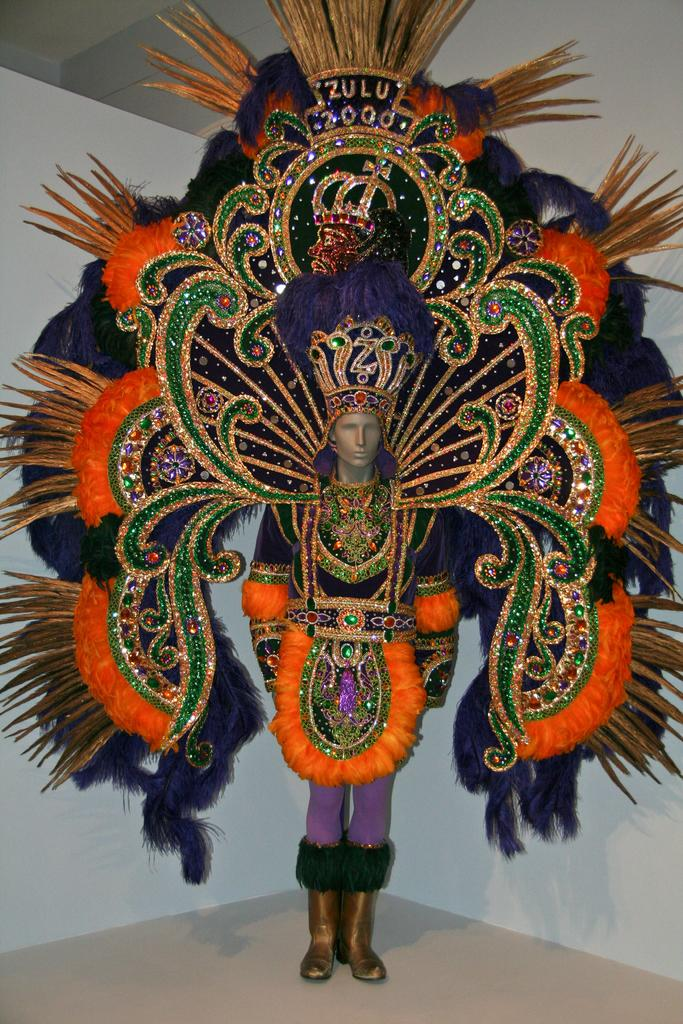What is the main subject in the foreground of the image? There is a mannequin in the foreground of the image. What is the mannequin wearing? The mannequin is wearing a carnival dress. What can be seen in the background of the image? There is a white wall in the background of the image. Can you tell me how many apples are on the mannequin's face in the image? There are no apples present on the mannequin's face in the image. Who is the friend standing next to the mannequin in the image? There is no friend standing next to the mannequin in the image; it is a mannequin and not a real person. 